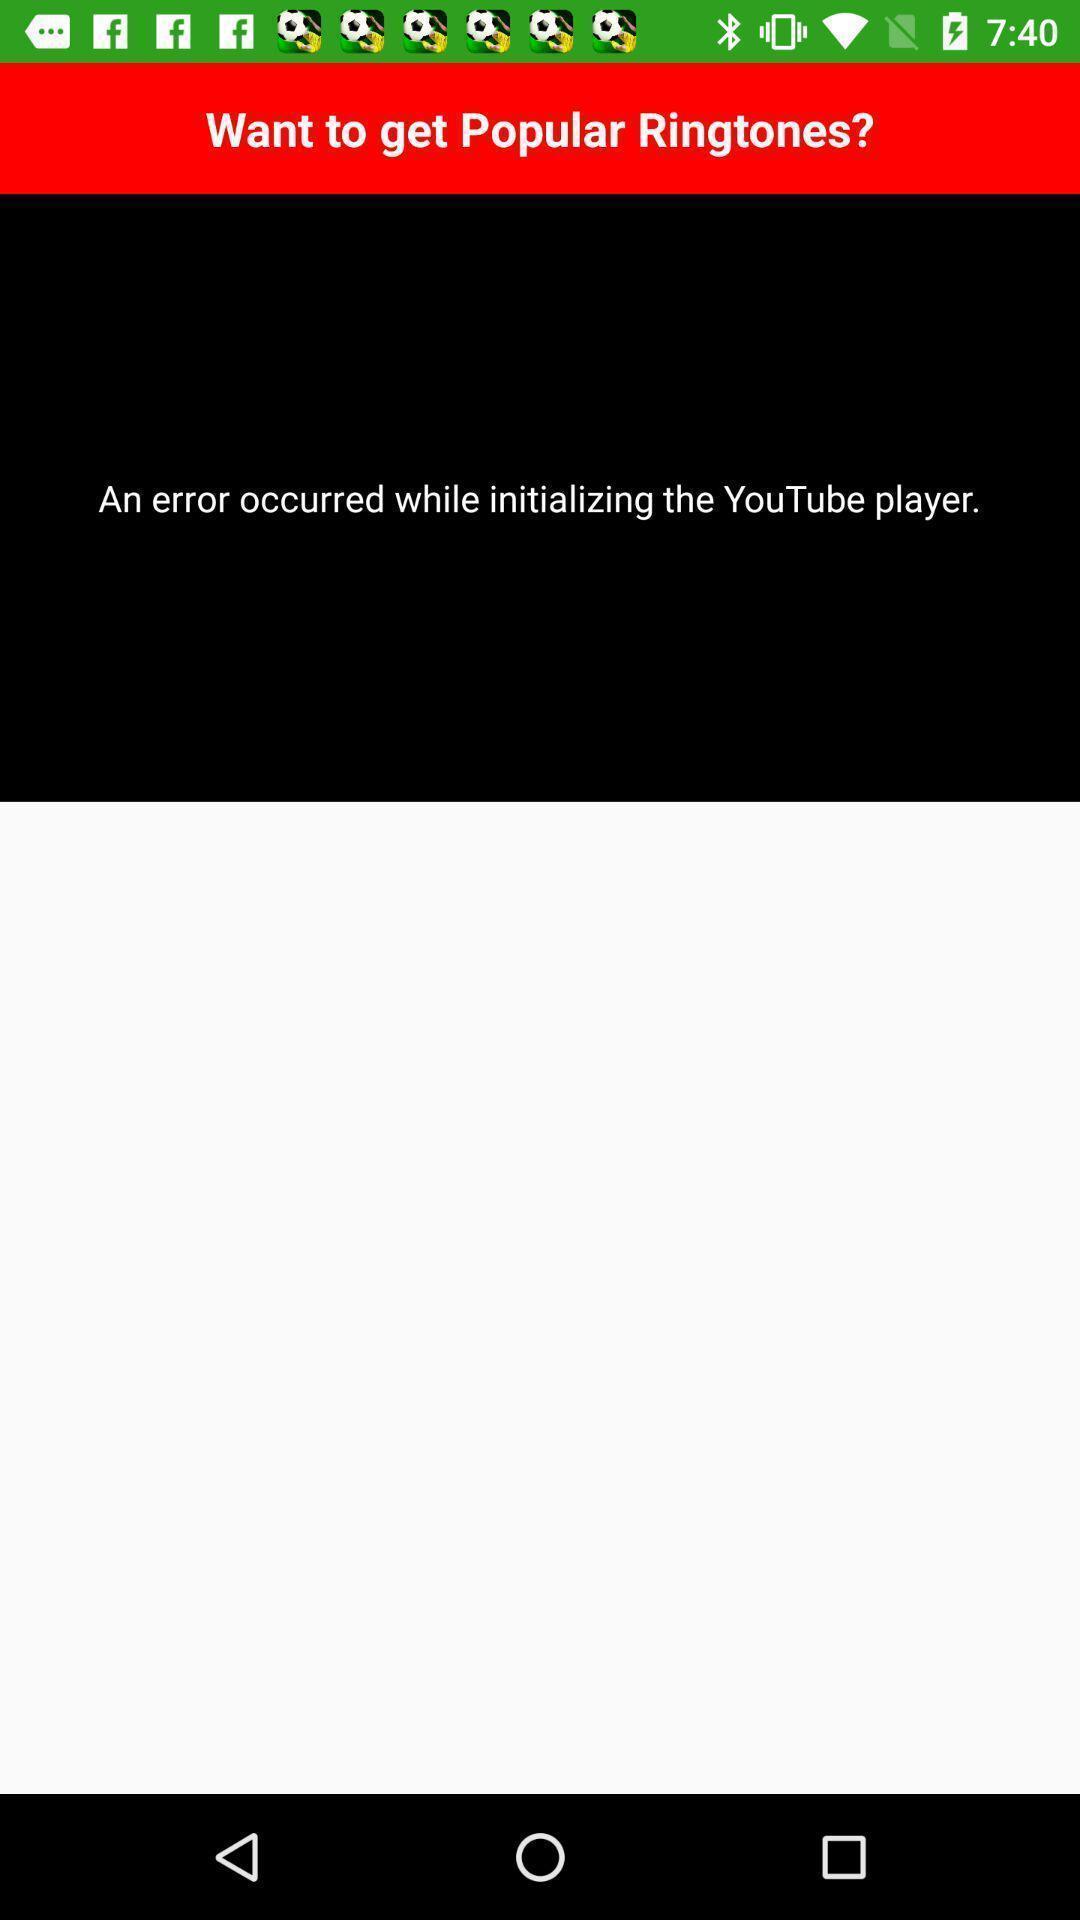Explain what's happening in this screen capture. Screen showing an error occurred while initializing a application. 